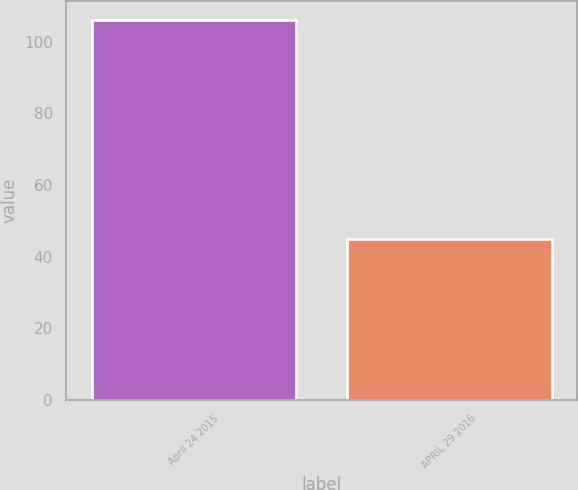Convert chart to OTSL. <chart><loc_0><loc_0><loc_500><loc_500><bar_chart><fcel>April 24 2015<fcel>APRIL 29 2016<nl><fcel>106<fcel>45<nl></chart> 